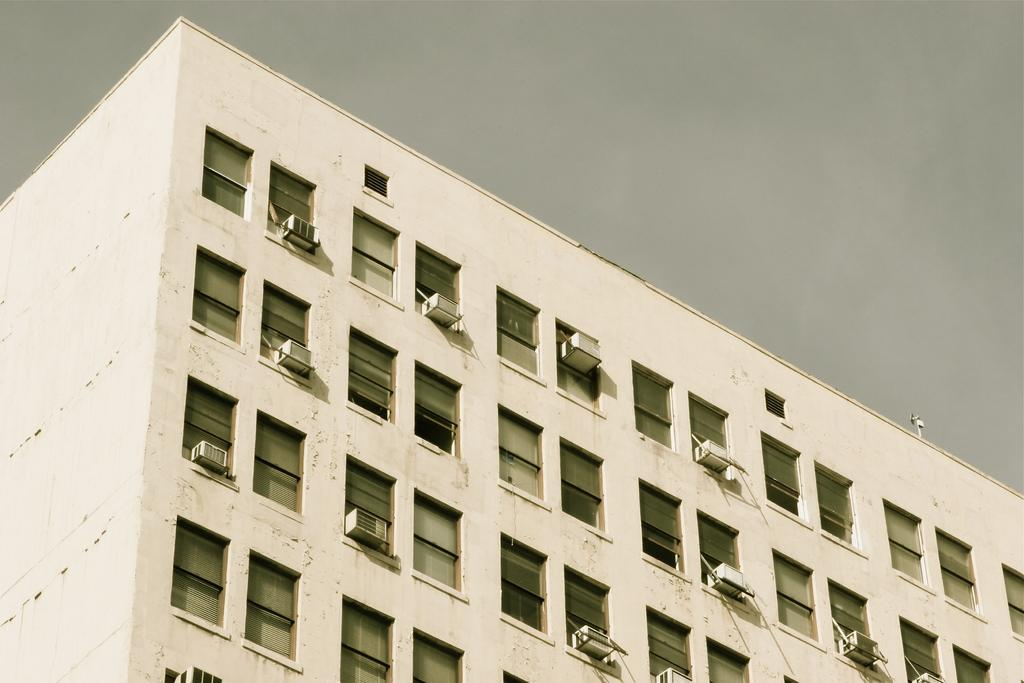Where was the image taken? The image is taken outdoors. What can be seen at the top of the image? The sky is visible at the top of the image. What type of structures are present in the image? There are walls, windows, and a roof in the image. How many air conditioners can be seen in the image? There are many air conditioners in the image. What type of seed is being planted in the image? There is no seed or planting activity present in the image. How does the glue hold the walls together in the image? There is no glue or indication of the walls being held together in the image. 